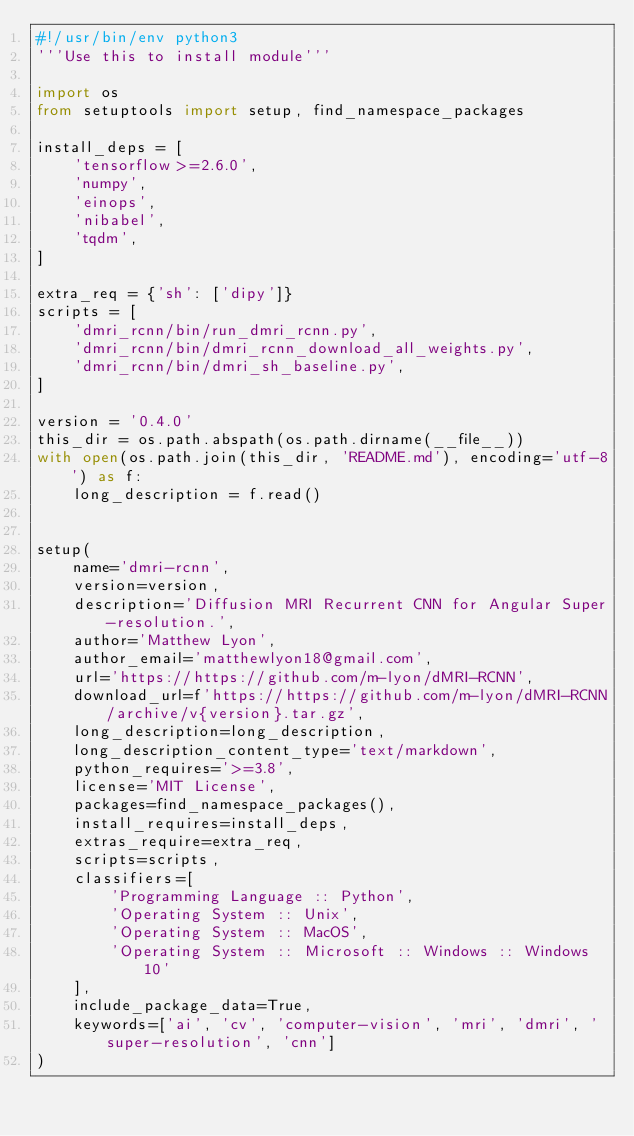<code> <loc_0><loc_0><loc_500><loc_500><_Python_>#!/usr/bin/env python3
'''Use this to install module'''

import os
from setuptools import setup, find_namespace_packages

install_deps = [
    'tensorflow>=2.6.0',
    'numpy',
    'einops',
    'nibabel',
    'tqdm',
]

extra_req = {'sh': ['dipy']}
scripts = [
    'dmri_rcnn/bin/run_dmri_rcnn.py',
    'dmri_rcnn/bin/dmri_rcnn_download_all_weights.py',
    'dmri_rcnn/bin/dmri_sh_baseline.py',
]

version = '0.4.0'
this_dir = os.path.abspath(os.path.dirname(__file__))
with open(os.path.join(this_dir, 'README.md'), encoding='utf-8') as f:
    long_description = f.read()


setup(
    name='dmri-rcnn',
    version=version,
    description='Diffusion MRI Recurrent CNN for Angular Super-resolution.',
    author='Matthew Lyon',
    author_email='matthewlyon18@gmail.com',
    url='https://https://github.com/m-lyon/dMRI-RCNN',
    download_url=f'https://https://github.com/m-lyon/dMRI-RCNN/archive/v{version}.tar.gz',
    long_description=long_description,
    long_description_content_type='text/markdown',
    python_requires='>=3.8',
    license='MIT License',
    packages=find_namespace_packages(),
    install_requires=install_deps,
    extras_require=extra_req,
    scripts=scripts,
    classifiers=[
        'Programming Language :: Python',
        'Operating System :: Unix',
        'Operating System :: MacOS',
        'Operating System :: Microsoft :: Windows :: Windows 10'
    ],
    include_package_data=True,
    keywords=['ai', 'cv', 'computer-vision', 'mri', 'dmri', 'super-resolution', 'cnn']
)
</code> 